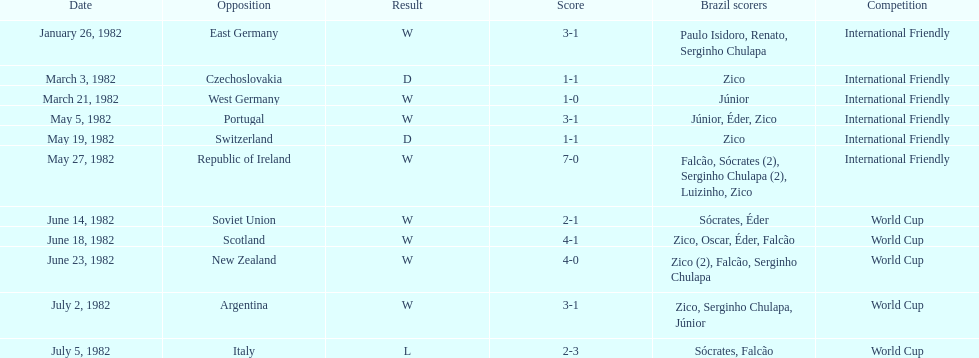Was the total goals scored on june 14, 1982 more than 6? No. 